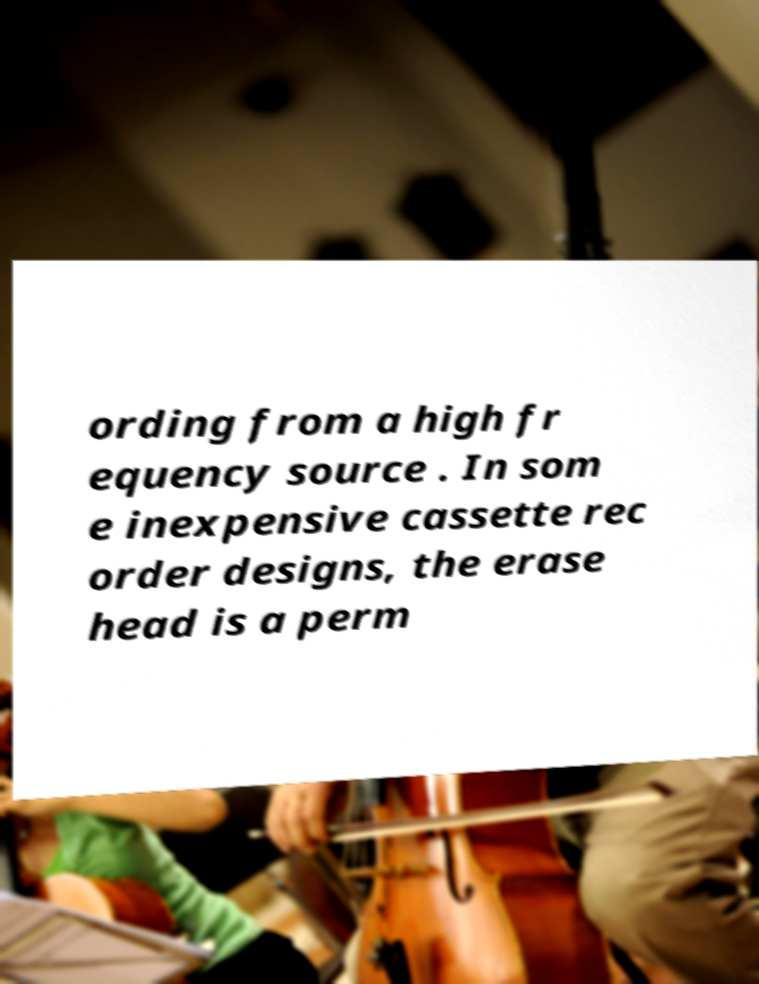Can you accurately transcribe the text from the provided image for me? ording from a high fr equency source . In som e inexpensive cassette rec order designs, the erase head is a perm 